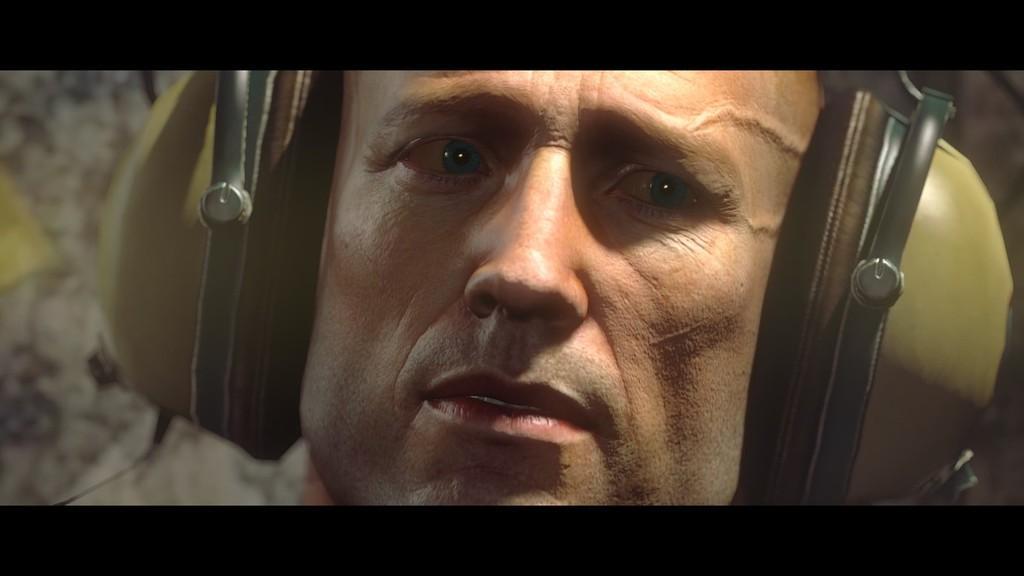In one or two sentences, can you explain what this image depicts? In this picture I can see a person with a headset, and there is blur background. 